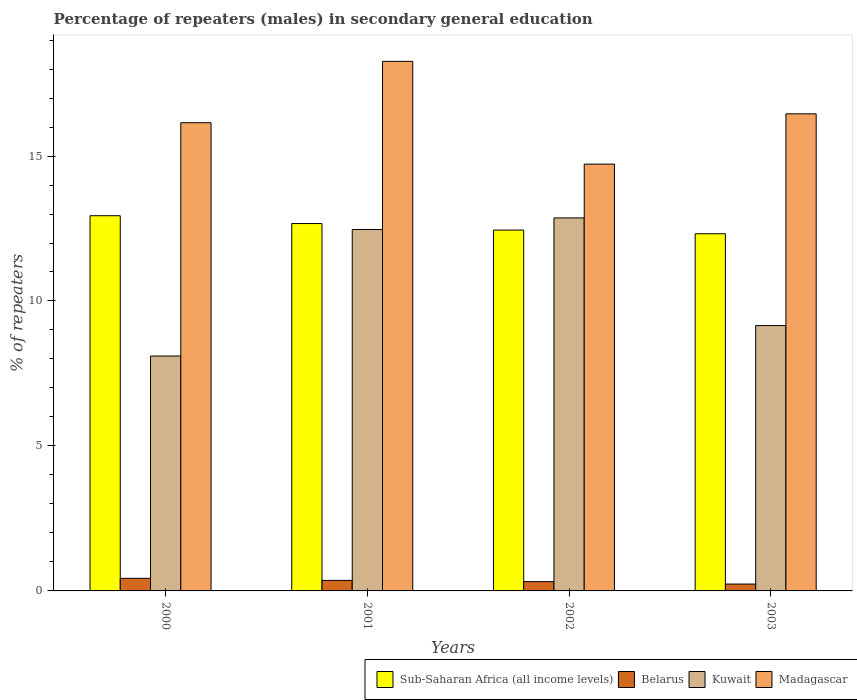How many different coloured bars are there?
Provide a short and direct response. 4. How many groups of bars are there?
Provide a succinct answer. 4. Are the number of bars per tick equal to the number of legend labels?
Give a very brief answer. Yes. Are the number of bars on each tick of the X-axis equal?
Offer a terse response. Yes. How many bars are there on the 3rd tick from the left?
Your answer should be compact. 4. How many bars are there on the 3rd tick from the right?
Make the answer very short. 4. What is the percentage of male repeaters in Belarus in 2002?
Your answer should be compact. 0.32. Across all years, what is the maximum percentage of male repeaters in Sub-Saharan Africa (all income levels)?
Make the answer very short. 12.94. Across all years, what is the minimum percentage of male repeaters in Sub-Saharan Africa (all income levels)?
Offer a very short reply. 12.32. In which year was the percentage of male repeaters in Sub-Saharan Africa (all income levels) maximum?
Your response must be concise. 2000. In which year was the percentage of male repeaters in Kuwait minimum?
Offer a terse response. 2000. What is the total percentage of male repeaters in Kuwait in the graph?
Offer a very short reply. 42.58. What is the difference between the percentage of male repeaters in Belarus in 2000 and that in 2001?
Keep it short and to the point. 0.07. What is the difference between the percentage of male repeaters in Sub-Saharan Africa (all income levels) in 2003 and the percentage of male repeaters in Kuwait in 2002?
Your answer should be very brief. -0.55. What is the average percentage of male repeaters in Belarus per year?
Give a very brief answer. 0.34. In the year 2002, what is the difference between the percentage of male repeaters in Kuwait and percentage of male repeaters in Sub-Saharan Africa (all income levels)?
Give a very brief answer. 0.42. What is the ratio of the percentage of male repeaters in Kuwait in 2000 to that in 2002?
Provide a succinct answer. 0.63. Is the percentage of male repeaters in Madagascar in 2000 less than that in 2001?
Make the answer very short. Yes. Is the difference between the percentage of male repeaters in Kuwait in 2001 and 2002 greater than the difference between the percentage of male repeaters in Sub-Saharan Africa (all income levels) in 2001 and 2002?
Your answer should be compact. No. What is the difference between the highest and the second highest percentage of male repeaters in Kuwait?
Offer a very short reply. 0.4. What is the difference between the highest and the lowest percentage of male repeaters in Kuwait?
Provide a short and direct response. 4.76. In how many years, is the percentage of male repeaters in Kuwait greater than the average percentage of male repeaters in Kuwait taken over all years?
Offer a very short reply. 2. Is it the case that in every year, the sum of the percentage of male repeaters in Belarus and percentage of male repeaters in Kuwait is greater than the sum of percentage of male repeaters in Sub-Saharan Africa (all income levels) and percentage of male repeaters in Madagascar?
Provide a short and direct response. No. What does the 1st bar from the left in 2003 represents?
Provide a short and direct response. Sub-Saharan Africa (all income levels). What does the 1st bar from the right in 2000 represents?
Offer a terse response. Madagascar. Is it the case that in every year, the sum of the percentage of male repeaters in Madagascar and percentage of male repeaters in Belarus is greater than the percentage of male repeaters in Sub-Saharan Africa (all income levels)?
Give a very brief answer. Yes. Are all the bars in the graph horizontal?
Give a very brief answer. No. How many years are there in the graph?
Make the answer very short. 4. Are the values on the major ticks of Y-axis written in scientific E-notation?
Provide a short and direct response. No. Does the graph contain grids?
Your answer should be compact. No. Where does the legend appear in the graph?
Ensure brevity in your answer.  Bottom right. How are the legend labels stacked?
Your answer should be compact. Horizontal. What is the title of the graph?
Your answer should be compact. Percentage of repeaters (males) in secondary general education. Does "Niger" appear as one of the legend labels in the graph?
Offer a very short reply. No. What is the label or title of the X-axis?
Your response must be concise. Years. What is the label or title of the Y-axis?
Give a very brief answer. % of repeaters. What is the % of repeaters of Sub-Saharan Africa (all income levels) in 2000?
Your answer should be compact. 12.94. What is the % of repeaters of Belarus in 2000?
Your response must be concise. 0.43. What is the % of repeaters in Kuwait in 2000?
Make the answer very short. 8.1. What is the % of repeaters of Madagascar in 2000?
Your answer should be very brief. 16.15. What is the % of repeaters of Sub-Saharan Africa (all income levels) in 2001?
Keep it short and to the point. 12.67. What is the % of repeaters in Belarus in 2001?
Your answer should be compact. 0.36. What is the % of repeaters in Kuwait in 2001?
Your answer should be compact. 12.47. What is the % of repeaters of Madagascar in 2001?
Make the answer very short. 18.27. What is the % of repeaters in Sub-Saharan Africa (all income levels) in 2002?
Ensure brevity in your answer.  12.45. What is the % of repeaters in Belarus in 2002?
Provide a succinct answer. 0.32. What is the % of repeaters in Kuwait in 2002?
Offer a terse response. 12.87. What is the % of repeaters in Madagascar in 2002?
Provide a short and direct response. 14.72. What is the % of repeaters of Sub-Saharan Africa (all income levels) in 2003?
Keep it short and to the point. 12.32. What is the % of repeaters in Belarus in 2003?
Provide a succinct answer. 0.24. What is the % of repeaters in Kuwait in 2003?
Offer a very short reply. 9.15. What is the % of repeaters in Madagascar in 2003?
Offer a terse response. 16.46. Across all years, what is the maximum % of repeaters in Sub-Saharan Africa (all income levels)?
Make the answer very short. 12.94. Across all years, what is the maximum % of repeaters of Belarus?
Your answer should be compact. 0.43. Across all years, what is the maximum % of repeaters in Kuwait?
Ensure brevity in your answer.  12.87. Across all years, what is the maximum % of repeaters in Madagascar?
Keep it short and to the point. 18.27. Across all years, what is the minimum % of repeaters of Sub-Saharan Africa (all income levels)?
Your answer should be compact. 12.32. Across all years, what is the minimum % of repeaters in Belarus?
Keep it short and to the point. 0.24. Across all years, what is the minimum % of repeaters of Kuwait?
Your answer should be compact. 8.1. Across all years, what is the minimum % of repeaters in Madagascar?
Your answer should be very brief. 14.72. What is the total % of repeaters in Sub-Saharan Africa (all income levels) in the graph?
Your response must be concise. 50.38. What is the total % of repeaters in Belarus in the graph?
Ensure brevity in your answer.  1.35. What is the total % of repeaters in Kuwait in the graph?
Make the answer very short. 42.58. What is the total % of repeaters of Madagascar in the graph?
Offer a terse response. 65.59. What is the difference between the % of repeaters of Sub-Saharan Africa (all income levels) in 2000 and that in 2001?
Your answer should be compact. 0.27. What is the difference between the % of repeaters of Belarus in 2000 and that in 2001?
Make the answer very short. 0.07. What is the difference between the % of repeaters of Kuwait in 2000 and that in 2001?
Keep it short and to the point. -4.36. What is the difference between the % of repeaters in Madagascar in 2000 and that in 2001?
Give a very brief answer. -2.12. What is the difference between the % of repeaters in Sub-Saharan Africa (all income levels) in 2000 and that in 2002?
Offer a very short reply. 0.49. What is the difference between the % of repeaters of Belarus in 2000 and that in 2002?
Your response must be concise. 0.11. What is the difference between the % of repeaters of Kuwait in 2000 and that in 2002?
Offer a terse response. -4.76. What is the difference between the % of repeaters in Madagascar in 2000 and that in 2002?
Keep it short and to the point. 1.43. What is the difference between the % of repeaters of Sub-Saharan Africa (all income levels) in 2000 and that in 2003?
Make the answer very short. 0.62. What is the difference between the % of repeaters of Belarus in 2000 and that in 2003?
Make the answer very short. 0.2. What is the difference between the % of repeaters of Kuwait in 2000 and that in 2003?
Your response must be concise. -1.05. What is the difference between the % of repeaters in Madagascar in 2000 and that in 2003?
Offer a terse response. -0.31. What is the difference between the % of repeaters of Sub-Saharan Africa (all income levels) in 2001 and that in 2002?
Keep it short and to the point. 0.22. What is the difference between the % of repeaters of Belarus in 2001 and that in 2002?
Your answer should be very brief. 0.04. What is the difference between the % of repeaters in Kuwait in 2001 and that in 2002?
Keep it short and to the point. -0.4. What is the difference between the % of repeaters of Madagascar in 2001 and that in 2002?
Offer a very short reply. 3.54. What is the difference between the % of repeaters of Sub-Saharan Africa (all income levels) in 2001 and that in 2003?
Your answer should be very brief. 0.35. What is the difference between the % of repeaters in Belarus in 2001 and that in 2003?
Your answer should be very brief. 0.13. What is the difference between the % of repeaters of Kuwait in 2001 and that in 2003?
Your answer should be compact. 3.31. What is the difference between the % of repeaters of Madagascar in 2001 and that in 2003?
Your answer should be compact. 1.81. What is the difference between the % of repeaters in Sub-Saharan Africa (all income levels) in 2002 and that in 2003?
Your response must be concise. 0.13. What is the difference between the % of repeaters of Belarus in 2002 and that in 2003?
Keep it short and to the point. 0.08. What is the difference between the % of repeaters in Kuwait in 2002 and that in 2003?
Ensure brevity in your answer.  3.71. What is the difference between the % of repeaters of Madagascar in 2002 and that in 2003?
Keep it short and to the point. -1.73. What is the difference between the % of repeaters in Sub-Saharan Africa (all income levels) in 2000 and the % of repeaters in Belarus in 2001?
Your response must be concise. 12.58. What is the difference between the % of repeaters of Sub-Saharan Africa (all income levels) in 2000 and the % of repeaters of Kuwait in 2001?
Ensure brevity in your answer.  0.47. What is the difference between the % of repeaters of Sub-Saharan Africa (all income levels) in 2000 and the % of repeaters of Madagascar in 2001?
Offer a very short reply. -5.32. What is the difference between the % of repeaters of Belarus in 2000 and the % of repeaters of Kuwait in 2001?
Offer a very short reply. -12.03. What is the difference between the % of repeaters in Belarus in 2000 and the % of repeaters in Madagascar in 2001?
Provide a succinct answer. -17.83. What is the difference between the % of repeaters of Kuwait in 2000 and the % of repeaters of Madagascar in 2001?
Provide a succinct answer. -10.16. What is the difference between the % of repeaters in Sub-Saharan Africa (all income levels) in 2000 and the % of repeaters in Belarus in 2002?
Your response must be concise. 12.62. What is the difference between the % of repeaters of Sub-Saharan Africa (all income levels) in 2000 and the % of repeaters of Kuwait in 2002?
Your answer should be compact. 0.08. What is the difference between the % of repeaters in Sub-Saharan Africa (all income levels) in 2000 and the % of repeaters in Madagascar in 2002?
Ensure brevity in your answer.  -1.78. What is the difference between the % of repeaters in Belarus in 2000 and the % of repeaters in Kuwait in 2002?
Provide a succinct answer. -12.43. What is the difference between the % of repeaters in Belarus in 2000 and the % of repeaters in Madagascar in 2002?
Offer a very short reply. -14.29. What is the difference between the % of repeaters of Kuwait in 2000 and the % of repeaters of Madagascar in 2002?
Provide a short and direct response. -6.62. What is the difference between the % of repeaters of Sub-Saharan Africa (all income levels) in 2000 and the % of repeaters of Belarus in 2003?
Your response must be concise. 12.7. What is the difference between the % of repeaters in Sub-Saharan Africa (all income levels) in 2000 and the % of repeaters in Kuwait in 2003?
Your answer should be compact. 3.79. What is the difference between the % of repeaters of Sub-Saharan Africa (all income levels) in 2000 and the % of repeaters of Madagascar in 2003?
Make the answer very short. -3.51. What is the difference between the % of repeaters in Belarus in 2000 and the % of repeaters in Kuwait in 2003?
Ensure brevity in your answer.  -8.72. What is the difference between the % of repeaters in Belarus in 2000 and the % of repeaters in Madagascar in 2003?
Your response must be concise. -16.02. What is the difference between the % of repeaters of Kuwait in 2000 and the % of repeaters of Madagascar in 2003?
Ensure brevity in your answer.  -8.35. What is the difference between the % of repeaters of Sub-Saharan Africa (all income levels) in 2001 and the % of repeaters of Belarus in 2002?
Your answer should be compact. 12.35. What is the difference between the % of repeaters in Sub-Saharan Africa (all income levels) in 2001 and the % of repeaters in Kuwait in 2002?
Offer a terse response. -0.19. What is the difference between the % of repeaters of Sub-Saharan Africa (all income levels) in 2001 and the % of repeaters of Madagascar in 2002?
Your answer should be compact. -2.05. What is the difference between the % of repeaters in Belarus in 2001 and the % of repeaters in Kuwait in 2002?
Provide a short and direct response. -12.5. What is the difference between the % of repeaters in Belarus in 2001 and the % of repeaters in Madagascar in 2002?
Keep it short and to the point. -14.36. What is the difference between the % of repeaters in Kuwait in 2001 and the % of repeaters in Madagascar in 2002?
Offer a terse response. -2.25. What is the difference between the % of repeaters of Sub-Saharan Africa (all income levels) in 2001 and the % of repeaters of Belarus in 2003?
Offer a terse response. 12.43. What is the difference between the % of repeaters in Sub-Saharan Africa (all income levels) in 2001 and the % of repeaters in Kuwait in 2003?
Your answer should be compact. 3.52. What is the difference between the % of repeaters in Sub-Saharan Africa (all income levels) in 2001 and the % of repeaters in Madagascar in 2003?
Make the answer very short. -3.78. What is the difference between the % of repeaters of Belarus in 2001 and the % of repeaters of Kuwait in 2003?
Offer a terse response. -8.79. What is the difference between the % of repeaters of Belarus in 2001 and the % of repeaters of Madagascar in 2003?
Make the answer very short. -16.09. What is the difference between the % of repeaters in Kuwait in 2001 and the % of repeaters in Madagascar in 2003?
Provide a succinct answer. -3.99. What is the difference between the % of repeaters of Sub-Saharan Africa (all income levels) in 2002 and the % of repeaters of Belarus in 2003?
Provide a succinct answer. 12.21. What is the difference between the % of repeaters of Sub-Saharan Africa (all income levels) in 2002 and the % of repeaters of Kuwait in 2003?
Your response must be concise. 3.29. What is the difference between the % of repeaters of Sub-Saharan Africa (all income levels) in 2002 and the % of repeaters of Madagascar in 2003?
Make the answer very short. -4.01. What is the difference between the % of repeaters of Belarus in 2002 and the % of repeaters of Kuwait in 2003?
Your response must be concise. -8.83. What is the difference between the % of repeaters of Belarus in 2002 and the % of repeaters of Madagascar in 2003?
Your response must be concise. -16.14. What is the difference between the % of repeaters in Kuwait in 2002 and the % of repeaters in Madagascar in 2003?
Provide a short and direct response. -3.59. What is the average % of repeaters of Sub-Saharan Africa (all income levels) per year?
Your answer should be compact. 12.59. What is the average % of repeaters in Belarus per year?
Your answer should be compact. 0.34. What is the average % of repeaters of Kuwait per year?
Offer a very short reply. 10.65. What is the average % of repeaters of Madagascar per year?
Offer a very short reply. 16.4. In the year 2000, what is the difference between the % of repeaters of Sub-Saharan Africa (all income levels) and % of repeaters of Belarus?
Your answer should be very brief. 12.51. In the year 2000, what is the difference between the % of repeaters of Sub-Saharan Africa (all income levels) and % of repeaters of Kuwait?
Offer a terse response. 4.84. In the year 2000, what is the difference between the % of repeaters of Sub-Saharan Africa (all income levels) and % of repeaters of Madagascar?
Your answer should be very brief. -3.21. In the year 2000, what is the difference between the % of repeaters in Belarus and % of repeaters in Kuwait?
Keep it short and to the point. -7.67. In the year 2000, what is the difference between the % of repeaters of Belarus and % of repeaters of Madagascar?
Ensure brevity in your answer.  -15.71. In the year 2000, what is the difference between the % of repeaters in Kuwait and % of repeaters in Madagascar?
Offer a very short reply. -8.05. In the year 2001, what is the difference between the % of repeaters in Sub-Saharan Africa (all income levels) and % of repeaters in Belarus?
Make the answer very short. 12.31. In the year 2001, what is the difference between the % of repeaters in Sub-Saharan Africa (all income levels) and % of repeaters in Kuwait?
Keep it short and to the point. 0.2. In the year 2001, what is the difference between the % of repeaters of Sub-Saharan Africa (all income levels) and % of repeaters of Madagascar?
Keep it short and to the point. -5.59. In the year 2001, what is the difference between the % of repeaters in Belarus and % of repeaters in Kuwait?
Offer a very short reply. -12.1. In the year 2001, what is the difference between the % of repeaters of Belarus and % of repeaters of Madagascar?
Keep it short and to the point. -17.9. In the year 2001, what is the difference between the % of repeaters in Kuwait and % of repeaters in Madagascar?
Keep it short and to the point. -5.8. In the year 2002, what is the difference between the % of repeaters of Sub-Saharan Africa (all income levels) and % of repeaters of Belarus?
Provide a succinct answer. 12.13. In the year 2002, what is the difference between the % of repeaters of Sub-Saharan Africa (all income levels) and % of repeaters of Kuwait?
Provide a short and direct response. -0.42. In the year 2002, what is the difference between the % of repeaters in Sub-Saharan Africa (all income levels) and % of repeaters in Madagascar?
Make the answer very short. -2.27. In the year 2002, what is the difference between the % of repeaters of Belarus and % of repeaters of Kuwait?
Provide a succinct answer. -12.54. In the year 2002, what is the difference between the % of repeaters of Belarus and % of repeaters of Madagascar?
Provide a succinct answer. -14.4. In the year 2002, what is the difference between the % of repeaters in Kuwait and % of repeaters in Madagascar?
Your answer should be compact. -1.86. In the year 2003, what is the difference between the % of repeaters in Sub-Saharan Africa (all income levels) and % of repeaters in Belarus?
Ensure brevity in your answer.  12.08. In the year 2003, what is the difference between the % of repeaters of Sub-Saharan Africa (all income levels) and % of repeaters of Kuwait?
Make the answer very short. 3.17. In the year 2003, what is the difference between the % of repeaters of Sub-Saharan Africa (all income levels) and % of repeaters of Madagascar?
Keep it short and to the point. -4.14. In the year 2003, what is the difference between the % of repeaters in Belarus and % of repeaters in Kuwait?
Your answer should be very brief. -8.91. In the year 2003, what is the difference between the % of repeaters in Belarus and % of repeaters in Madagascar?
Ensure brevity in your answer.  -16.22. In the year 2003, what is the difference between the % of repeaters of Kuwait and % of repeaters of Madagascar?
Make the answer very short. -7.3. What is the ratio of the % of repeaters of Sub-Saharan Africa (all income levels) in 2000 to that in 2001?
Offer a very short reply. 1.02. What is the ratio of the % of repeaters in Belarus in 2000 to that in 2001?
Your answer should be compact. 1.2. What is the ratio of the % of repeaters of Kuwait in 2000 to that in 2001?
Provide a succinct answer. 0.65. What is the ratio of the % of repeaters in Madagascar in 2000 to that in 2001?
Your answer should be compact. 0.88. What is the ratio of the % of repeaters of Sub-Saharan Africa (all income levels) in 2000 to that in 2002?
Keep it short and to the point. 1.04. What is the ratio of the % of repeaters in Belarus in 2000 to that in 2002?
Provide a succinct answer. 1.36. What is the ratio of the % of repeaters in Kuwait in 2000 to that in 2002?
Provide a short and direct response. 0.63. What is the ratio of the % of repeaters in Madagascar in 2000 to that in 2002?
Your response must be concise. 1.1. What is the ratio of the % of repeaters of Sub-Saharan Africa (all income levels) in 2000 to that in 2003?
Keep it short and to the point. 1.05. What is the ratio of the % of repeaters of Belarus in 2000 to that in 2003?
Provide a short and direct response. 1.83. What is the ratio of the % of repeaters of Kuwait in 2000 to that in 2003?
Make the answer very short. 0.89. What is the ratio of the % of repeaters in Madagascar in 2000 to that in 2003?
Keep it short and to the point. 0.98. What is the ratio of the % of repeaters of Belarus in 2001 to that in 2002?
Ensure brevity in your answer.  1.13. What is the ratio of the % of repeaters of Kuwait in 2001 to that in 2002?
Give a very brief answer. 0.97. What is the ratio of the % of repeaters of Madagascar in 2001 to that in 2002?
Your response must be concise. 1.24. What is the ratio of the % of repeaters of Sub-Saharan Africa (all income levels) in 2001 to that in 2003?
Provide a short and direct response. 1.03. What is the ratio of the % of repeaters in Belarus in 2001 to that in 2003?
Keep it short and to the point. 1.53. What is the ratio of the % of repeaters in Kuwait in 2001 to that in 2003?
Provide a succinct answer. 1.36. What is the ratio of the % of repeaters in Madagascar in 2001 to that in 2003?
Make the answer very short. 1.11. What is the ratio of the % of repeaters in Sub-Saharan Africa (all income levels) in 2002 to that in 2003?
Your answer should be very brief. 1.01. What is the ratio of the % of repeaters in Belarus in 2002 to that in 2003?
Provide a succinct answer. 1.35. What is the ratio of the % of repeaters of Kuwait in 2002 to that in 2003?
Provide a succinct answer. 1.41. What is the ratio of the % of repeaters in Madagascar in 2002 to that in 2003?
Your answer should be very brief. 0.89. What is the difference between the highest and the second highest % of repeaters of Sub-Saharan Africa (all income levels)?
Your answer should be very brief. 0.27. What is the difference between the highest and the second highest % of repeaters in Belarus?
Ensure brevity in your answer.  0.07. What is the difference between the highest and the second highest % of repeaters in Kuwait?
Give a very brief answer. 0.4. What is the difference between the highest and the second highest % of repeaters of Madagascar?
Provide a succinct answer. 1.81. What is the difference between the highest and the lowest % of repeaters in Sub-Saharan Africa (all income levels)?
Ensure brevity in your answer.  0.62. What is the difference between the highest and the lowest % of repeaters in Belarus?
Keep it short and to the point. 0.2. What is the difference between the highest and the lowest % of repeaters of Kuwait?
Offer a terse response. 4.76. What is the difference between the highest and the lowest % of repeaters of Madagascar?
Ensure brevity in your answer.  3.54. 